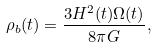<formula> <loc_0><loc_0><loc_500><loc_500>\rho _ { b } ( t ) = \frac { 3 H ^ { 2 } ( t ) \Omega ( t ) } { 8 \pi G } ,</formula> 